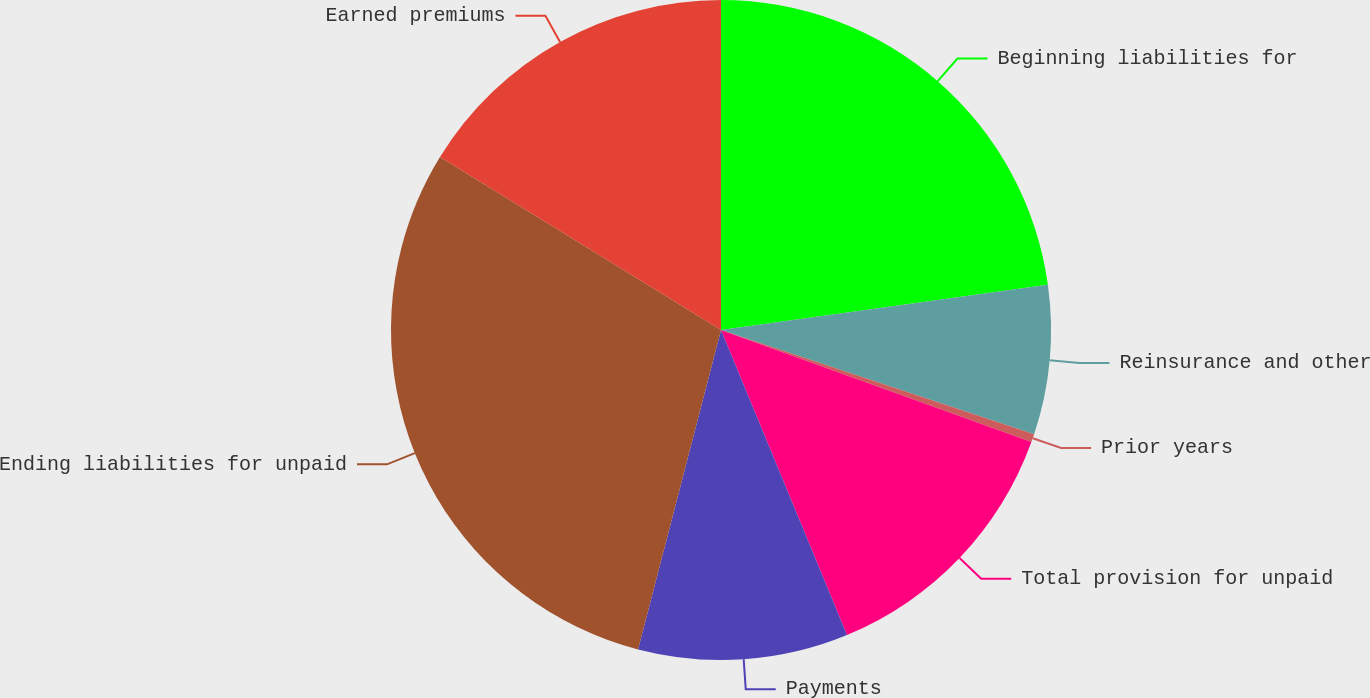Convert chart. <chart><loc_0><loc_0><loc_500><loc_500><pie_chart><fcel>Beginning liabilities for<fcel>Reinsurance and other<fcel>Prior years<fcel>Total provision for unpaid<fcel>Payments<fcel>Ending liabilities for unpaid<fcel>Earned premiums<nl><fcel>22.81%<fcel>7.31%<fcel>0.4%<fcel>13.25%<fcel>10.28%<fcel>29.74%<fcel>16.22%<nl></chart> 